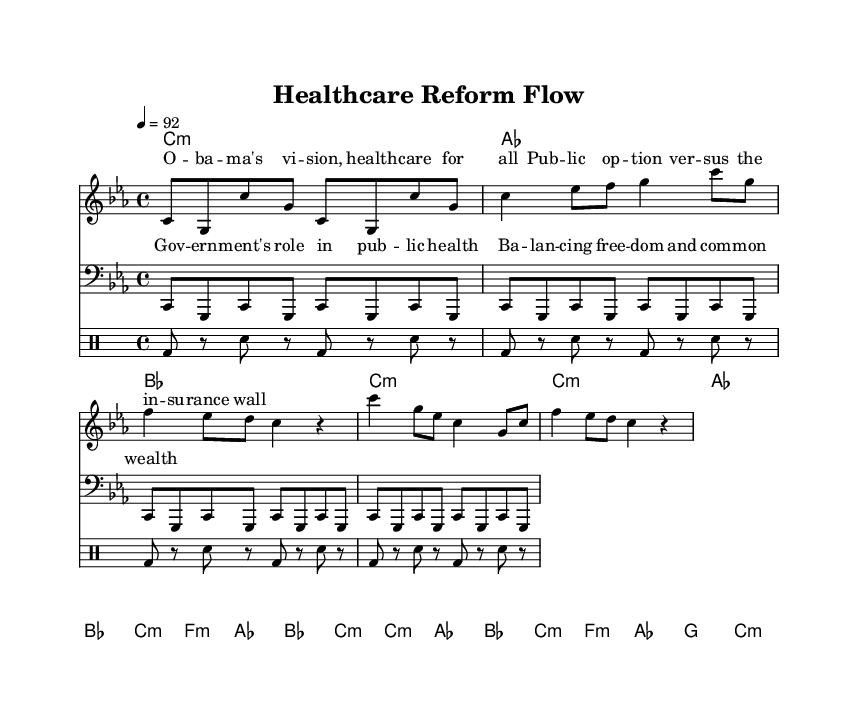What is the key signature of this music? The key signature is C minor, which has three flats. This can be identified at the beginning of the sheet music, where the flat symbols are presented.
Answer: C minor What is the time signature of this music? The time signature is 4/4, indicated right at the beginning of the sheet music. It signifies that there are four beats in each measure.
Answer: 4/4 What is the tempo marking of this piece? The tempo marking is 92 beats per minute, which is specified in the sheet music. It helps determine the pace at which the piece should be performed.
Answer: 92 How many measures are in the verse section? The verse section contains eight measures. This can be counted in the music notation that comprises the verse lyrics and corresponding notes.
Answer: 8 What is the primary theme of the lyrics? The primary theme of the lyrics discusses the government's role in public health and insurance. This is evident from the content of both the verse and chorus sections.
Answer: Government's role in public health In which section do the lyrics mention "public option"? The phrase "public option" appears in the verse section. The lyrics are laid out directly beneath the melody and can be identified by reading through the verse text.
Answer: Verse What are the two contrasting elements discussed in the chorus? The contrasting elements are “freedom” and “common wealth,” mentioned in the chorus lyrics. This duality emphasizes the balancing act in the government's role in health care.
Answer: Freedom and common wealth 